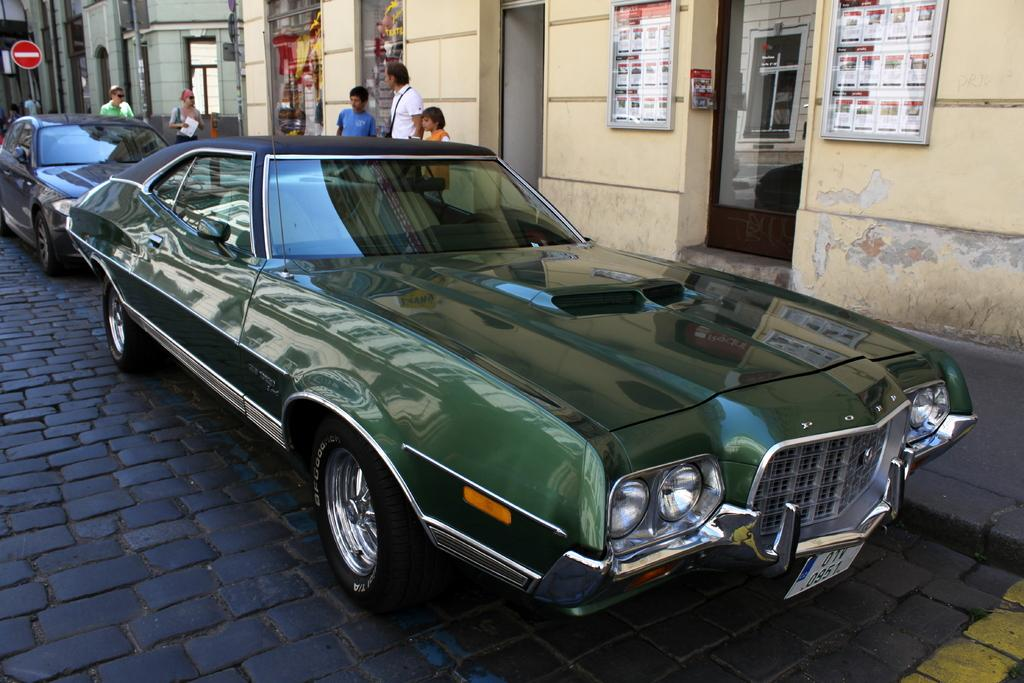What can be seen parked in the image? There are cars parked in the image. What else is visible in the image besides the parked cars? There are people standing in the image, as well as buildings, a sign board, and advertisement boards on the wall. Can you see a crown on top of any of the buildings in the image? There is no crown visible on top of any of the buildings in the image. Are there any eggs being blown in the image? There are no eggs or blowing activity present in the image. 